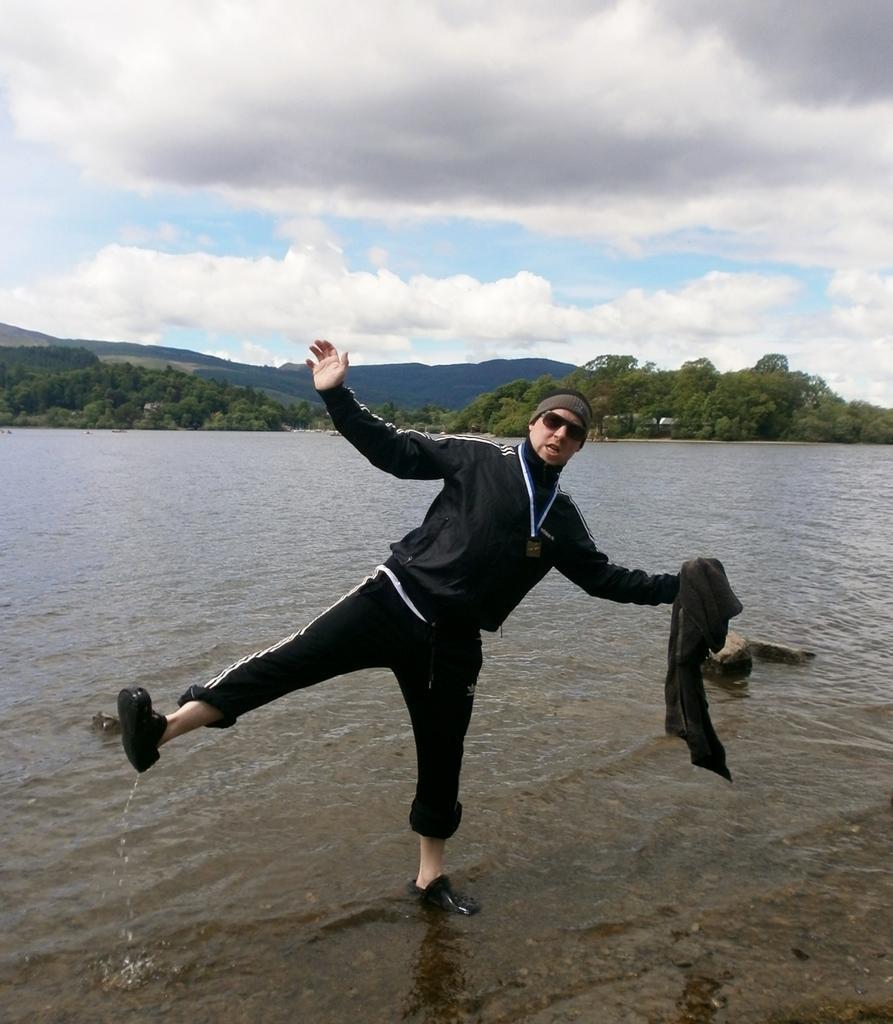Describe this image in one or two sentences. In this image there is a person standing on a single leg is posing for the camera, behind the person there is a river, behind the river there are trees, in the background of the image there are mountains, at the top of the image there are clouds in the sky. 